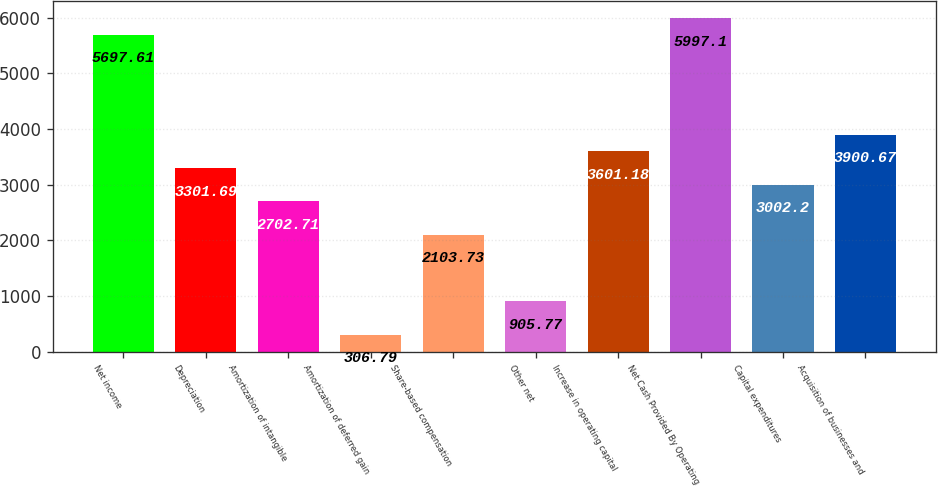<chart> <loc_0><loc_0><loc_500><loc_500><bar_chart><fcel>Net income<fcel>Depreciation<fcel>Amortization of intangible<fcel>Amortization of deferred gain<fcel>Share-based compensation<fcel>Other net<fcel>Increase in operating capital<fcel>Net Cash Provided By Operating<fcel>Capital expenditures<fcel>Acquisition of businesses and<nl><fcel>5697.61<fcel>3301.69<fcel>2702.71<fcel>306.79<fcel>2103.73<fcel>905.77<fcel>3601.18<fcel>5997.1<fcel>3002.2<fcel>3900.67<nl></chart> 